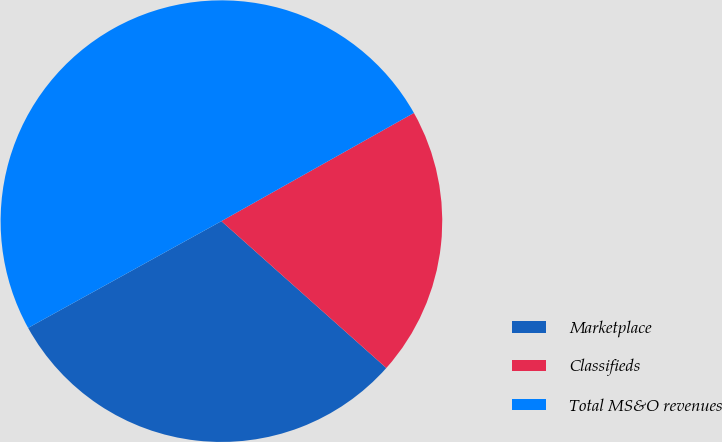Convert chart to OTSL. <chart><loc_0><loc_0><loc_500><loc_500><pie_chart><fcel>Marketplace<fcel>Classifieds<fcel>Total MS&O revenues<nl><fcel>30.39%<fcel>19.73%<fcel>49.88%<nl></chart> 